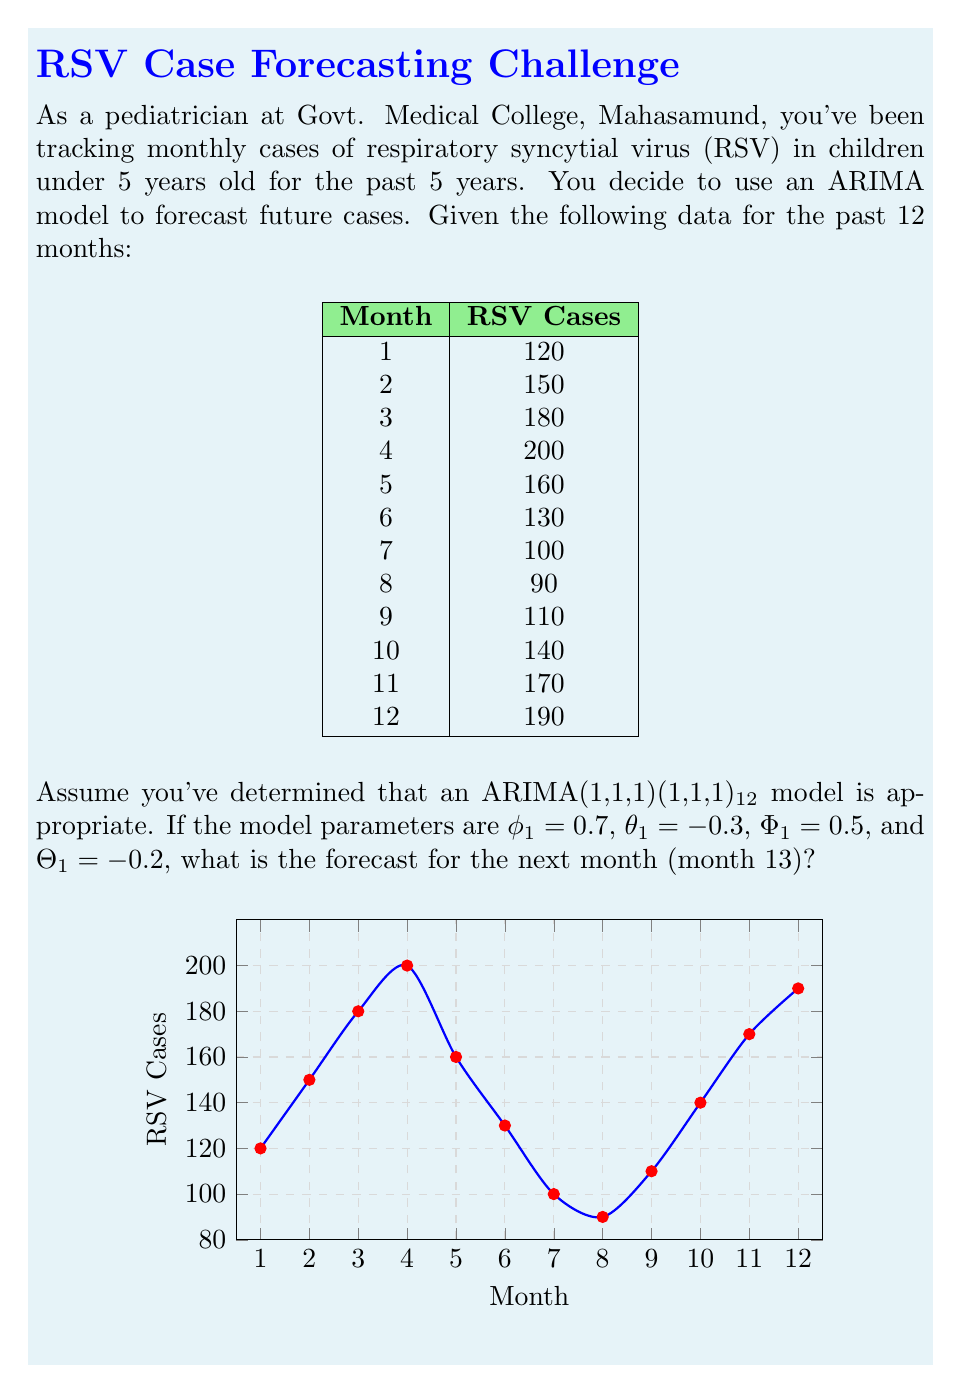Give your solution to this math problem. Let's approach this step-by-step:

1) The ARIMA(1,1,1)(1,1,1)₁₂ model can be written as:

   $$(1-\phi_1B)(1-\Phi_1B^{12})(1-B)(1-B^{12})y_t = (1+\theta_1B)(1+\Theta_1B^{12})\epsilon_t$$

2) We need to calculate the differenced series. First, let's take a regular difference:

   $w_t = y_t - y_{t-1}$

   For the last two months:
   $w_{12} = 190 - 170 = 20$
   $w_{11} = 170 - 140 = 30$

3) Now, let's take a seasonal difference of the differenced series:

   $v_t = w_t - w_{t-12}$

   We don't have enough data to calculate this directly, so we'll assume $v_{12} = w_{12} = 20$.

4) The forecast equation for the differenced and seasonally differenced series is:

   $v_{13} = \phi_1v_{12} + \Phi_1v_1 - \phi_1\Phi_1v_0 + \epsilon_{13} + \theta_1\epsilon_{12} + \Theta_1\epsilon_1 - \theta_1\Theta_1\epsilon_0$

5) We don't have values for $v_1$, $v_0$, $\epsilon_{12}$, $\epsilon_1$, and $\epsilon_0$. In practice, we would estimate these from the data. For this example, let's assume they're all zero.

6) Plugging in the known values:

   $v_{13} = 0.7 * 20 + 0 - 0 + 0 + 0 + 0 - 0 = 14$

7) To get back to the original series, we need to "undo" the differencing:

   $w_{13} = v_{13} + w_1 = 14 + w_1$
   $y_{13} = w_{13} + y_{12} = (14 + w_1) + 190$

8) We don't know $w_1$, but we can estimate it as the average of the known $w$ values:
   $w_1 \approx (20 + 30) / 2 = 25$

9) Therefore, our forecast is:

   $y_{13} = (14 + 25) + 190 = 229$
Answer: 229 RSV cases 